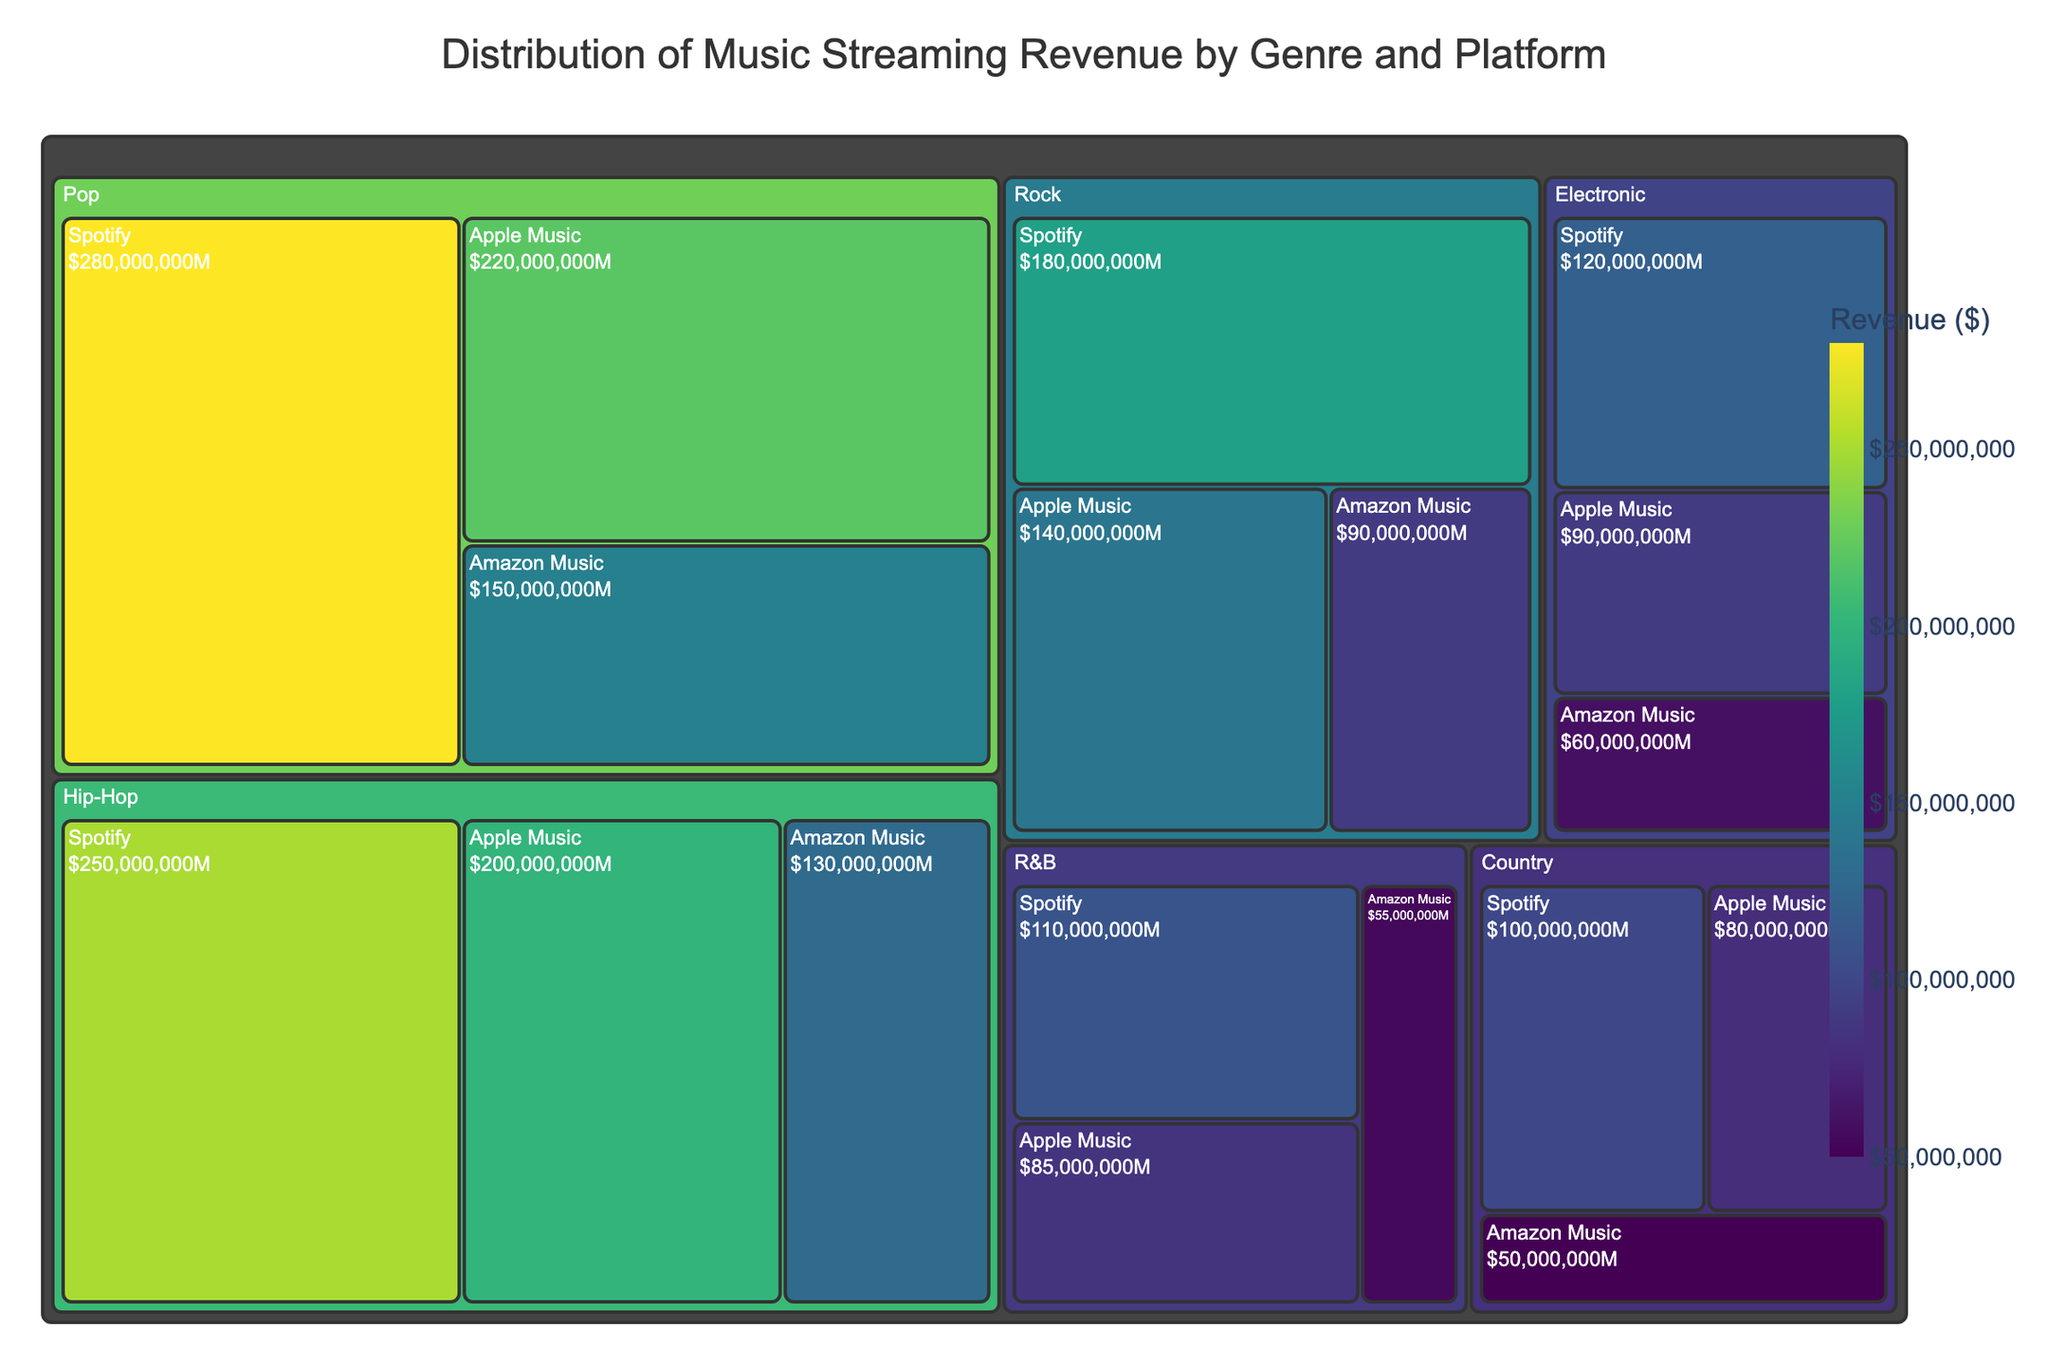What's the title of the figure? The title is prominently displayed at the top of the figure in a larger font size. It provides an overview of what the figure is about.
Answer: Distribution of Music Streaming Revenue by Genre and Platform How much revenue does Pop generate on Spotify? Locate the Pop genre group and identify the tile corresponding to Spotify. The revenue value is either on the tile label or seen in the hover data.
Answer: $280,000,000 Which genre generates more revenue on Apple Music, Rock or Hip-Hop? Compare the revenue value tiles for Rock and Hip-Hop under Apple Music. The one with a higher revenue value will be the answer.
Answer: Hip-Hop What's the total revenue generated by Electronic across all platforms? Sum the revenue values for Electronic on Spotify, Apple Music, and Amazon Music. These values are $120,000,000, $90,000,000, and $60,000,000, respectively.
Answer: $270,000,000 What is the primary color scheme used in the figure? The color scheme for the figure can be observed on the tiles and the color bar. It's often a gradient representing revenue values.
Answer: Viridis Compare the revenue of Hip-Hop on Amazon Music to Country on Spotify. Which is higher? Find the revenue values for Hip-Hop on Amazon Music and Country on Spotify, which are $130,000,000 and $100,000,000, respectively.
Answer: Hip-Hop on Amazon Music Which music platform generates the least revenue for R&B? Look for the smallest revenue value tile under R&B among Spotify, Apple Music, and Amazon Music.
Answer: Amazon Music What is the difference in revenue between Pop on Spotify and Rock on Apple Music? Subtract the revenue of Rock on Apple Music ($140,000,000) from the revenue of Pop on Spotify ($280,000,000).
Answer: $140,000,000 Identify the platform with the highest revenue for each genre and explain the process. By inspecting the revenue tiles of each genre and comparing their sizes and values, you can identify the highest revenue platform for each genre. For example, in Pop, Spotify has the highest revenue at $280,000,000, and so on.
Answer: Pop: Spotify, Rock: Spotify, Hip-Hop: Spotify, Electronic: Spotify, Country: Spotify, R&B: Spotify 